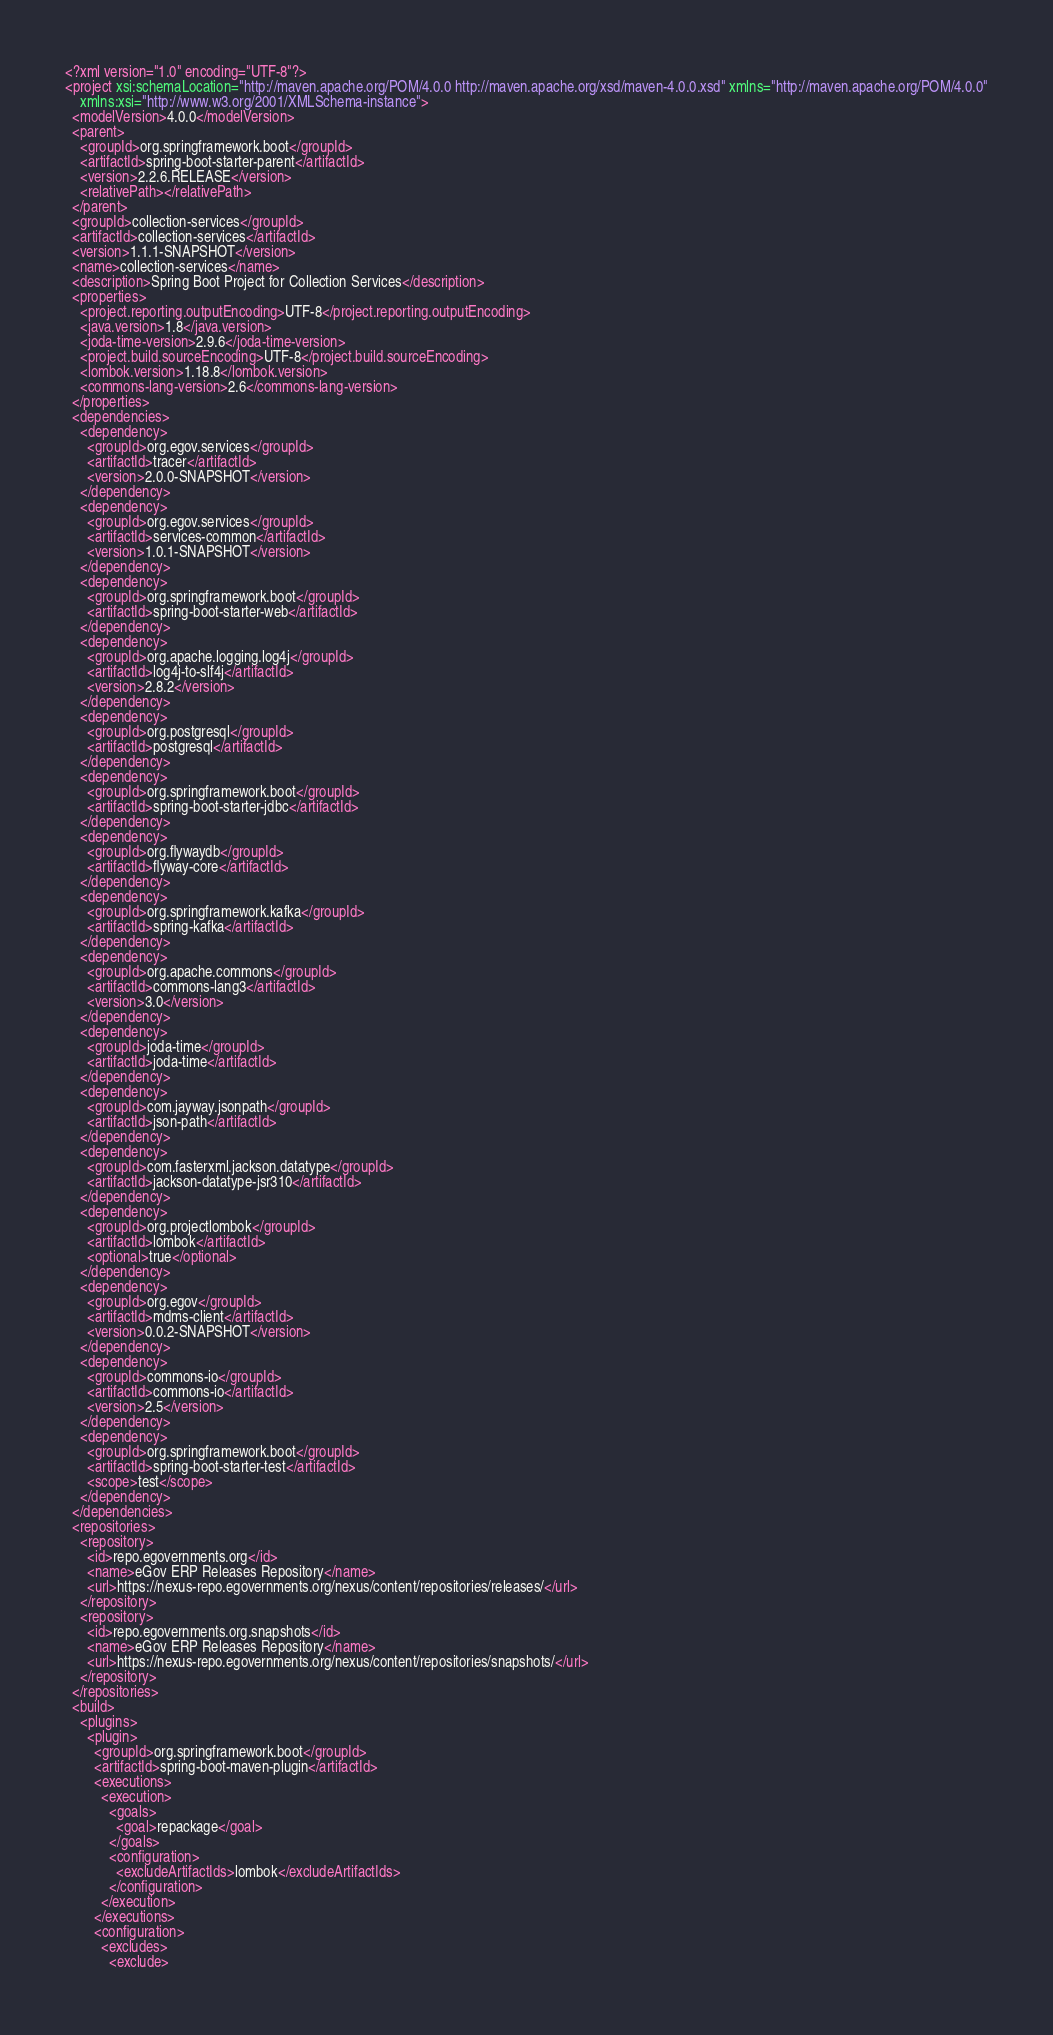<code> <loc_0><loc_0><loc_500><loc_500><_XML_><?xml version="1.0" encoding="UTF-8"?>
<project xsi:schemaLocation="http://maven.apache.org/POM/4.0.0 http://maven.apache.org/xsd/maven-4.0.0.xsd" xmlns="http://maven.apache.org/POM/4.0.0"
    xmlns:xsi="http://www.w3.org/2001/XMLSchema-instance">
  <modelVersion>4.0.0</modelVersion>
  <parent>
    <groupId>org.springframework.boot</groupId>
    <artifactId>spring-boot-starter-parent</artifactId>
    <version>2.2.6.RELEASE</version>
    <relativePath></relativePath>
  </parent>
  <groupId>collection-services</groupId>
  <artifactId>collection-services</artifactId>
  <version>1.1.1-SNAPSHOT</version>
  <name>collection-services</name>
  <description>Spring Boot Project for Collection Services</description>
  <properties>
    <project.reporting.outputEncoding>UTF-8</project.reporting.outputEncoding>
    <java.version>1.8</java.version>
    <joda-time-version>2.9.6</joda-time-version>
    <project.build.sourceEncoding>UTF-8</project.build.sourceEncoding>
    <lombok.version>1.18.8</lombok.version>
    <commons-lang-version>2.6</commons-lang-version>
  </properties>
  <dependencies>
    <dependency>
      <groupId>org.egov.services</groupId>
      <artifactId>tracer</artifactId>
      <version>2.0.0-SNAPSHOT</version>
    </dependency>
    <dependency>
      <groupId>org.egov.services</groupId>
      <artifactId>services-common</artifactId>
      <version>1.0.1-SNAPSHOT</version>
    </dependency>
    <dependency>
      <groupId>org.springframework.boot</groupId>
      <artifactId>spring-boot-starter-web</artifactId>
    </dependency>
    <dependency>
      <groupId>org.apache.logging.log4j</groupId>
      <artifactId>log4j-to-slf4j</artifactId>
      <version>2.8.2</version>
    </dependency>
    <dependency>
      <groupId>org.postgresql</groupId>
      <artifactId>postgresql</artifactId>
    </dependency>
    <dependency>
      <groupId>org.springframework.boot</groupId>
      <artifactId>spring-boot-starter-jdbc</artifactId>
    </dependency>
    <dependency>
      <groupId>org.flywaydb</groupId>
      <artifactId>flyway-core</artifactId>
    </dependency>
    <dependency>
      <groupId>org.springframework.kafka</groupId>
      <artifactId>spring-kafka</artifactId>
    </dependency>
    <dependency>
      <groupId>org.apache.commons</groupId>
      <artifactId>commons-lang3</artifactId>
      <version>3.0</version>
    </dependency>
    <dependency>
      <groupId>joda-time</groupId>
      <artifactId>joda-time</artifactId>
    </dependency>
    <dependency>
      <groupId>com.jayway.jsonpath</groupId>
      <artifactId>json-path</artifactId>
    </dependency>
    <dependency>
      <groupId>com.fasterxml.jackson.datatype</groupId>
      <artifactId>jackson-datatype-jsr310</artifactId>
    </dependency>
    <dependency>
      <groupId>org.projectlombok</groupId>
      <artifactId>lombok</artifactId>
      <optional>true</optional>
    </dependency>
    <dependency>
      <groupId>org.egov</groupId>
      <artifactId>mdms-client</artifactId>
      <version>0.0.2-SNAPSHOT</version>
    </dependency>
    <dependency>
      <groupId>commons-io</groupId>
      <artifactId>commons-io</artifactId>
      <version>2.5</version>
    </dependency>
    <dependency>
      <groupId>org.springframework.boot</groupId>
      <artifactId>spring-boot-starter-test</artifactId>
      <scope>test</scope>
    </dependency>
  </dependencies>
  <repositories>
    <repository>
      <id>repo.egovernments.org</id>
      <name>eGov ERP Releases Repository</name>
      <url>https://nexus-repo.egovernments.org/nexus/content/repositories/releases/</url>
    </repository>
    <repository>
      <id>repo.egovernments.org.snapshots</id>
      <name>eGov ERP Releases Repository</name>
      <url>https://nexus-repo.egovernments.org/nexus/content/repositories/snapshots/</url>
    </repository>
  </repositories>
  <build>
    <plugins>
      <plugin>
        <groupId>org.springframework.boot</groupId>
        <artifactId>spring-boot-maven-plugin</artifactId>
        <executions>
          <execution>
            <goals>
              <goal>repackage</goal>
            </goals>
            <configuration>
              <excludeArtifactIds>lombok</excludeArtifactIds>
            </configuration>
          </execution>
        </executions>
        <configuration>
          <excludes>
            <exclude></code> 